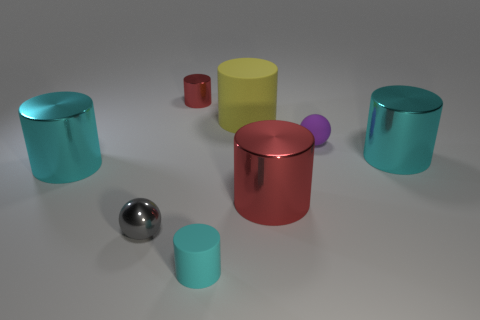There is a small thing that is to the right of the tiny cyan cylinder; does it have the same shape as the small gray shiny object? Yes, the item to the right of the tiny cyan cylinder and the small gray shiny object both appear to have spherical shapes, with a highly reflective, smooth surface, suggesting they could be metallic balls. 